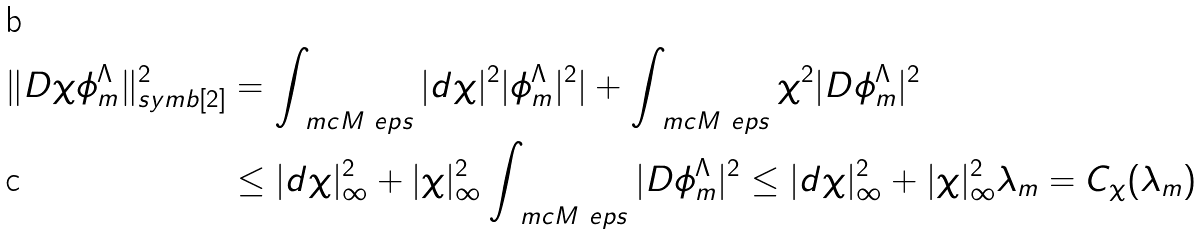<formula> <loc_0><loc_0><loc_500><loc_500>\| D \chi \phi ^ { \Lambda } _ { m } \| ^ { 2 } _ { \L s y m b [ 2 ] } & = \int _ { \ m c M _ { \ } e p s } | d \chi | ^ { 2 } | \phi ^ { \Lambda } _ { m } | ^ { 2 } | + \int _ { \ m c M _ { \ } e p s } \chi ^ { 2 } | D \phi ^ { \Lambda } _ { m } | ^ { 2 } \\ & \leq | d \chi | _ { \infty } ^ { 2 } + | \chi | _ { \infty } ^ { 2 } \int _ { \ m c M _ { \ } e p s } | D \phi ^ { \Lambda } _ { m } | ^ { 2 } \leq | d \chi | _ { \infty } ^ { 2 } + | \chi | _ { \infty } ^ { 2 } \lambda _ { m } = C _ { \chi } ( \lambda _ { m } )</formula> 